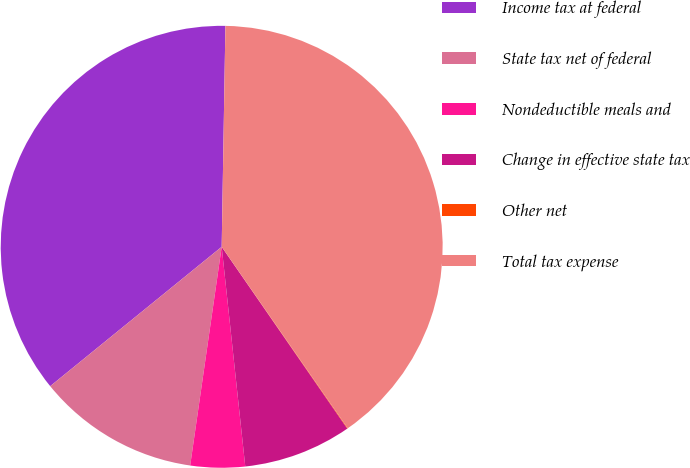Convert chart. <chart><loc_0><loc_0><loc_500><loc_500><pie_chart><fcel>Income tax at federal<fcel>State tax net of federal<fcel>Nondeductible meals and<fcel>Change in effective state tax<fcel>Other net<fcel>Total tax expense<nl><fcel>36.13%<fcel>11.86%<fcel>3.98%<fcel>7.92%<fcel>0.04%<fcel>40.07%<nl></chart> 